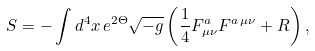Convert formula to latex. <formula><loc_0><loc_0><loc_500><loc_500>S = - \int d ^ { 4 } x \, e ^ { 2 \Theta } \sqrt { - g } \left ( \frac { 1 } { 4 } F ^ { a } _ { \mu \nu } F ^ { a \, \mu \nu } + R \right ) ,</formula> 